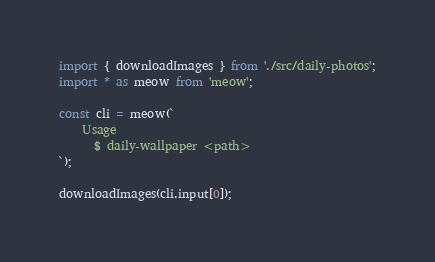<code> <loc_0><loc_0><loc_500><loc_500><_TypeScript_>import { downloadImages } from './src/daily-photos';
import * as meow from 'meow';

const cli = meow(`
    Usage
      $ daily-wallpaper <path>
`);

downloadImages(cli.input[0]);
</code> 